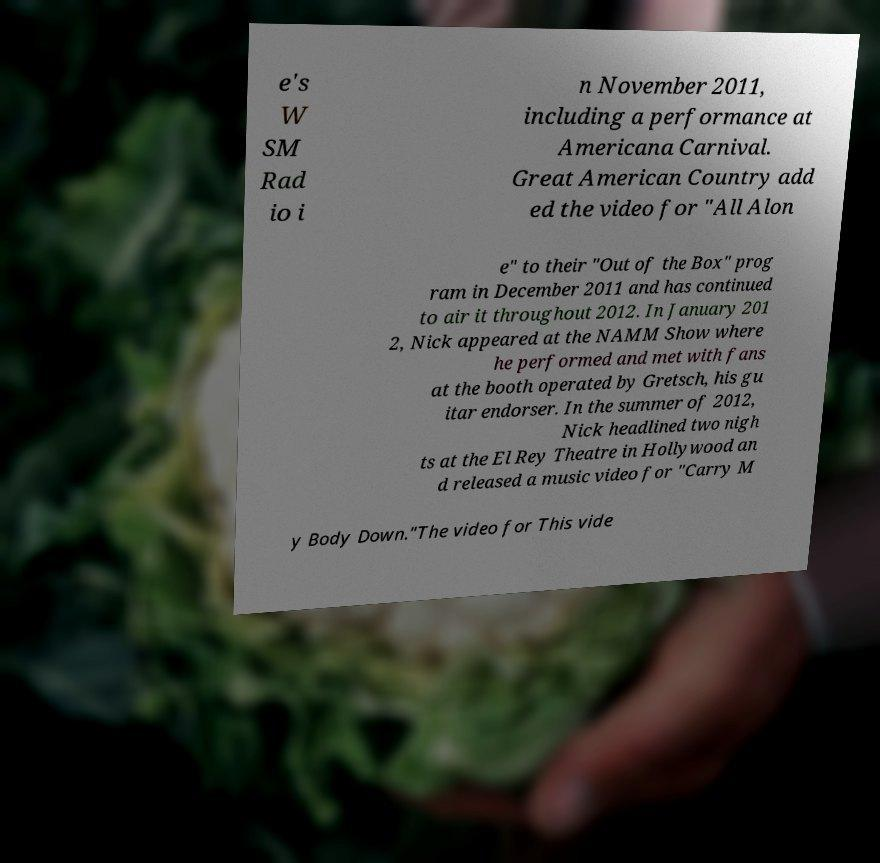Please read and relay the text visible in this image. What does it say? e's W SM Rad io i n November 2011, including a performance at Americana Carnival. Great American Country add ed the video for "All Alon e" to their "Out of the Box" prog ram in December 2011 and has continued to air it throughout 2012. In January 201 2, Nick appeared at the NAMM Show where he performed and met with fans at the booth operated by Gretsch, his gu itar endorser. In the summer of 2012, Nick headlined two nigh ts at the El Rey Theatre in Hollywood an d released a music video for "Carry M y Body Down."The video for This vide 